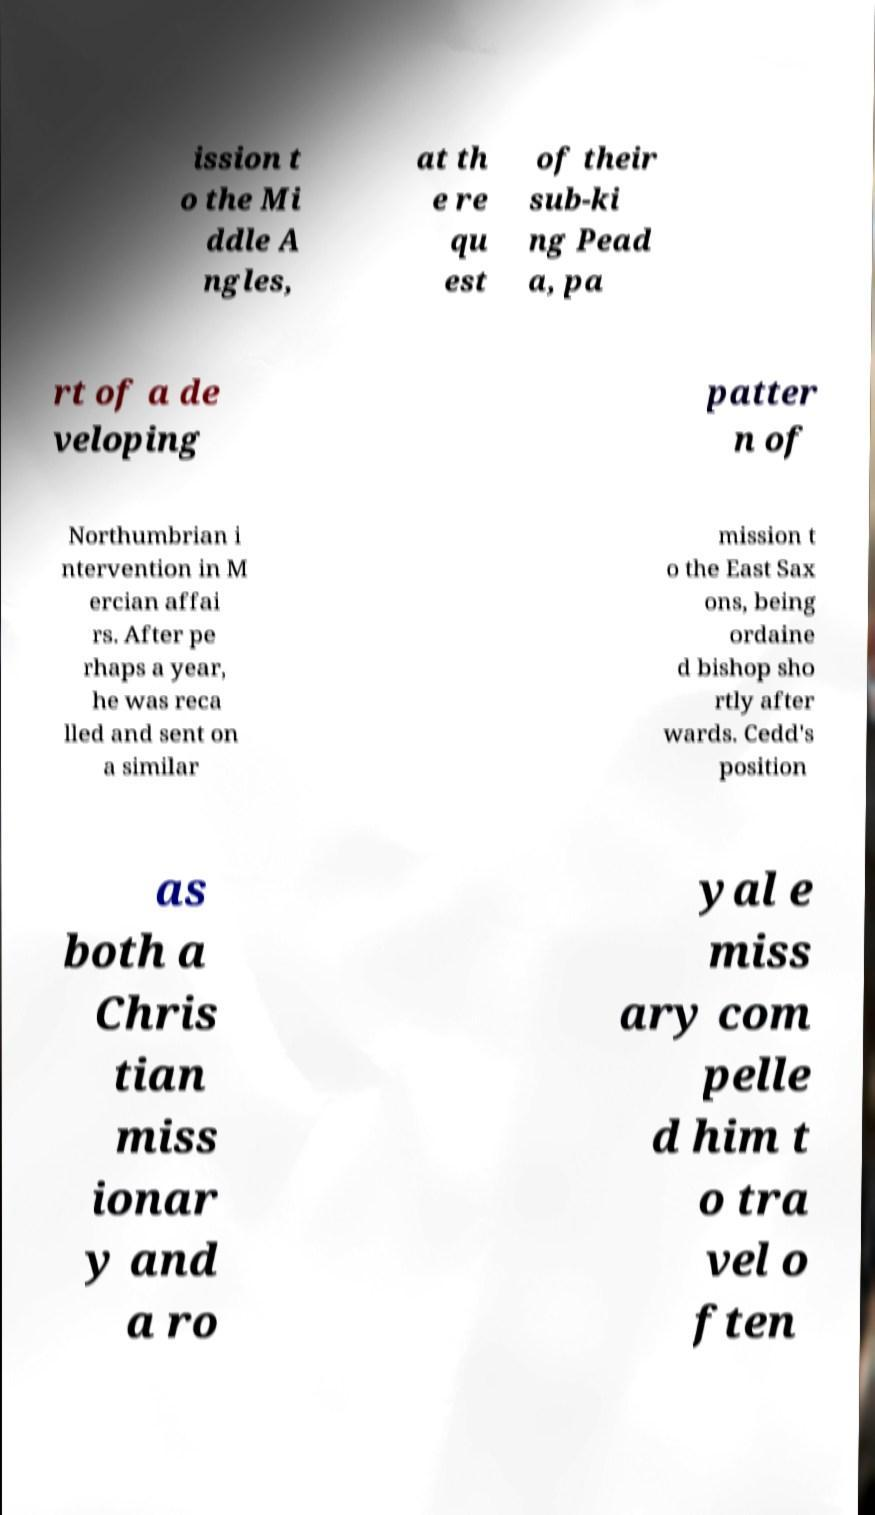Please identify and transcribe the text found in this image. ission t o the Mi ddle A ngles, at th e re qu est of their sub-ki ng Pead a, pa rt of a de veloping patter n of Northumbrian i ntervention in M ercian affai rs. After pe rhaps a year, he was reca lled and sent on a similar mission t o the East Sax ons, being ordaine d bishop sho rtly after wards. Cedd's position as both a Chris tian miss ionar y and a ro yal e miss ary com pelle d him t o tra vel o ften 